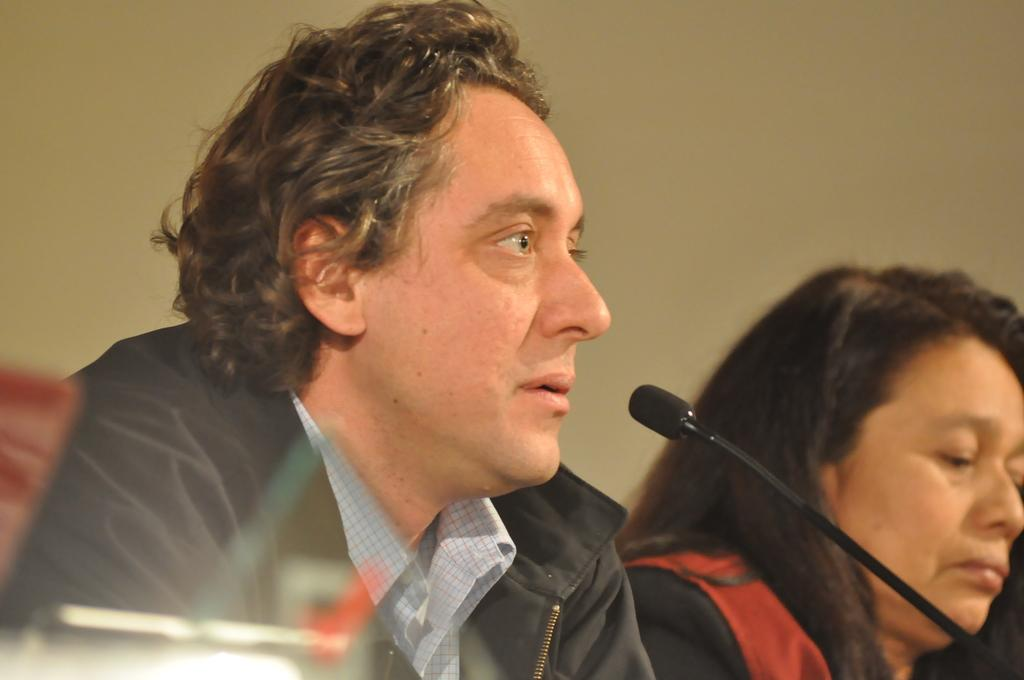What can be seen in the image? There are people in the image. What object is present that is typically used for amplifying sound? There is a mic in the image. What is visible in the background of the image? There is a wall in the background of the image. What type of crime is being committed in the image? There is no indication of any crime being committed in the image. What is the cause of the people's presence in the image? The facts provided do not give any information about the cause of the people's presence in the image. 